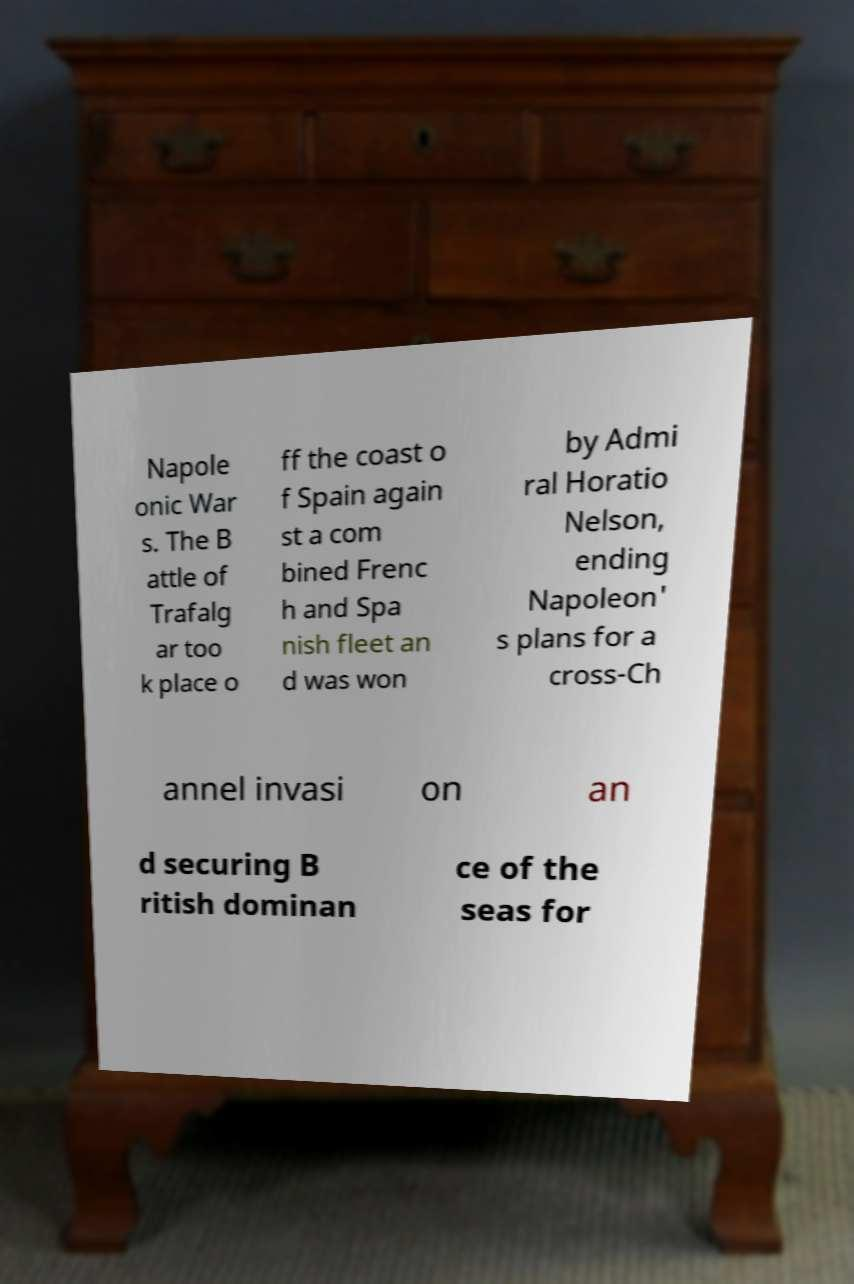What messages or text are displayed in this image? I need them in a readable, typed format. Napole onic War s. The B attle of Trafalg ar too k place o ff the coast o f Spain again st a com bined Frenc h and Spa nish fleet an d was won by Admi ral Horatio Nelson, ending Napoleon' s plans for a cross-Ch annel invasi on an d securing B ritish dominan ce of the seas for 